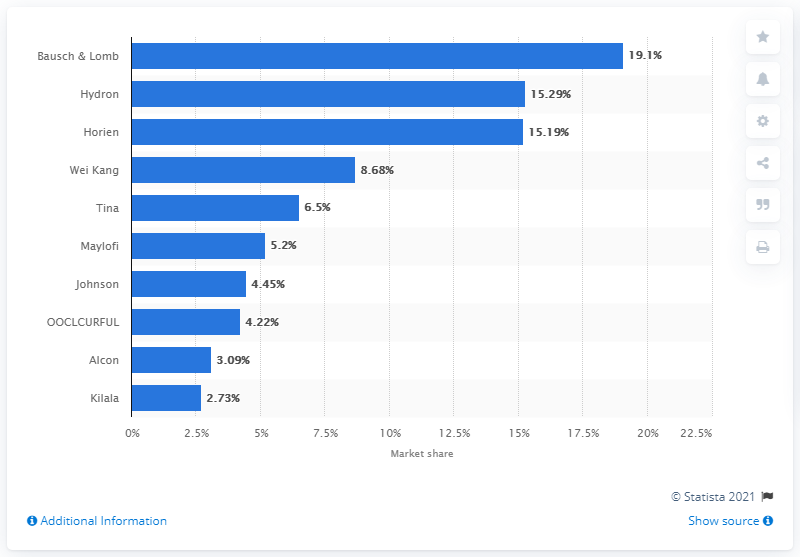Specify some key components in this picture. Bausch & Lomb held a market share of 19.1% on Tmall.com during a specific time period. Bausch & Lomb was the largest contact lens vendor on Tmall.com. 